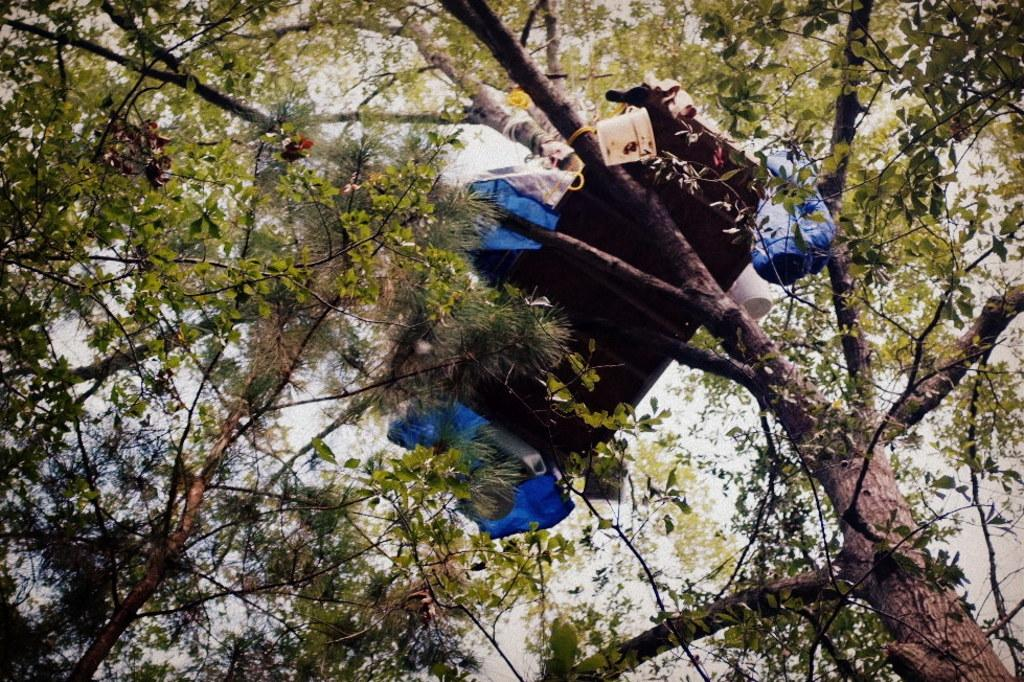What is on the tree in the image? There is an object on a tree in the image that resembles a bed. What other objects can be seen in the image? There is a bucket and plastic covers visible in the image. What type of vegetation is present in the image? There are trees in the image. What can be seen in the background of the image? The sky is visible in the background of the image. What type of dog is sitting under the tree in the image? There is no dog present in the image; it only features an object on a tree, a bucket, plastic covers, trees, and the sky in the background. 